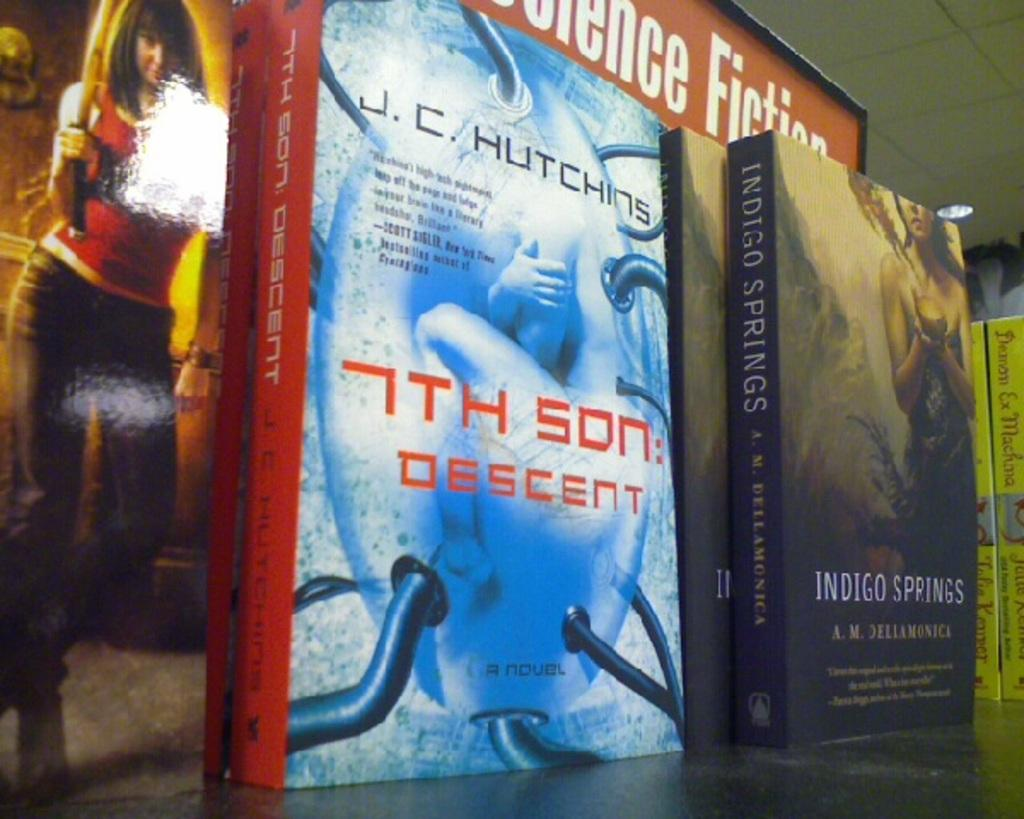Provide a one-sentence caption for the provided image. A Science Fiction book display with books called 7th Son: Descent and Indigo Springs. 